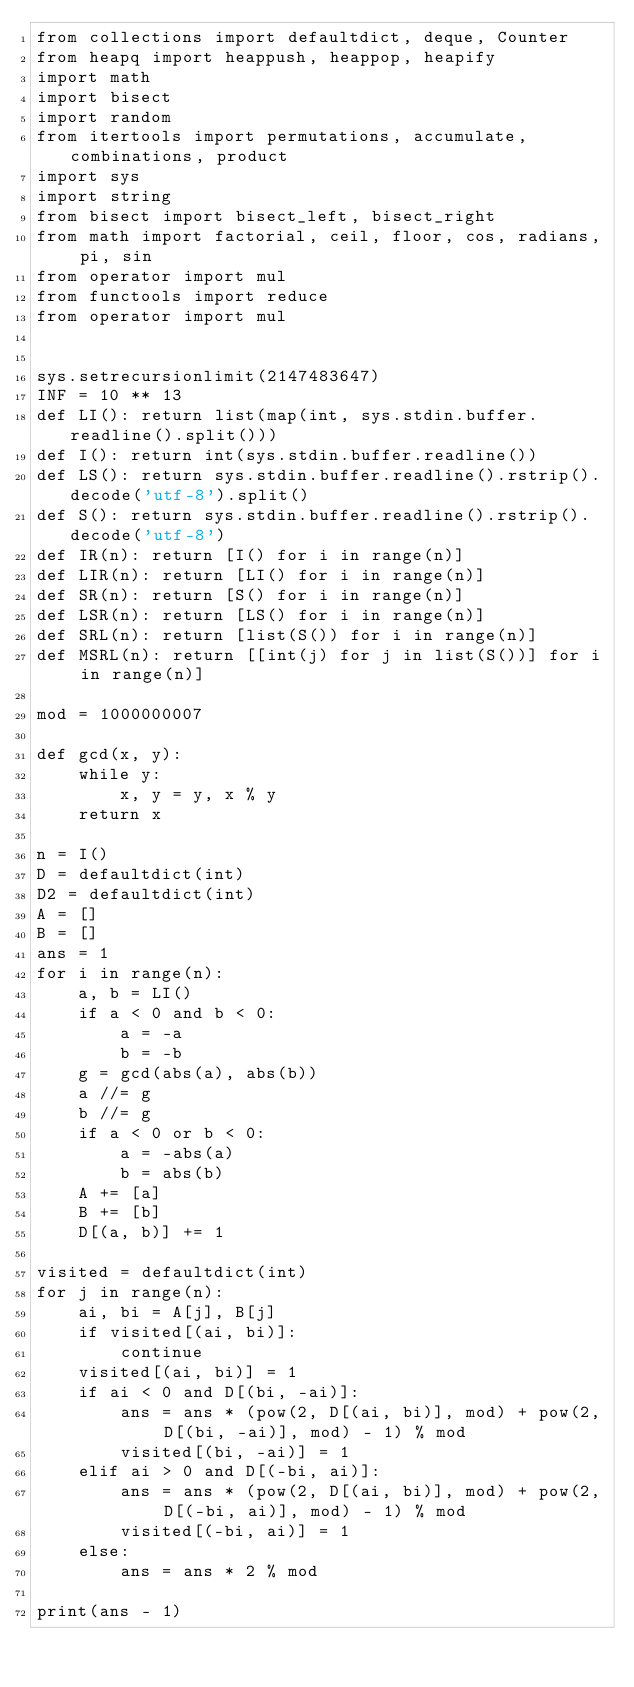<code> <loc_0><loc_0><loc_500><loc_500><_Python_>from collections import defaultdict, deque, Counter
from heapq import heappush, heappop, heapify
import math
import bisect
import random
from itertools import permutations, accumulate, combinations, product
import sys
import string
from bisect import bisect_left, bisect_right
from math import factorial, ceil, floor, cos, radians, pi, sin
from operator import mul
from functools import reduce
from operator import mul


sys.setrecursionlimit(2147483647)
INF = 10 ** 13
def LI(): return list(map(int, sys.stdin.buffer.readline().split()))
def I(): return int(sys.stdin.buffer.readline())
def LS(): return sys.stdin.buffer.readline().rstrip().decode('utf-8').split()
def S(): return sys.stdin.buffer.readline().rstrip().decode('utf-8')
def IR(n): return [I() for i in range(n)]
def LIR(n): return [LI() for i in range(n)]
def SR(n): return [S() for i in range(n)]
def LSR(n): return [LS() for i in range(n)]
def SRL(n): return [list(S()) for i in range(n)]
def MSRL(n): return [[int(j) for j in list(S())] for i in range(n)]

mod = 1000000007

def gcd(x, y):
    while y:
        x, y = y, x % y
    return x

n = I()
D = defaultdict(int)
D2 = defaultdict(int)
A = []
B = []
ans = 1
for i in range(n):
    a, b = LI()
    if a < 0 and b < 0:
        a = -a
        b = -b
    g = gcd(abs(a), abs(b))
    a //= g
    b //= g
    if a < 0 or b < 0:
        a = -abs(a)
        b = abs(b)
    A += [a]
    B += [b]
    D[(a, b)] += 1

visited = defaultdict(int)
for j in range(n):
    ai, bi = A[j], B[j]
    if visited[(ai, bi)]:
        continue
    visited[(ai, bi)] = 1
    if ai < 0 and D[(bi, -ai)]:
        ans = ans * (pow(2, D[(ai, bi)], mod) + pow(2, D[(bi, -ai)], mod) - 1) % mod
        visited[(bi, -ai)] = 1
    elif ai > 0 and D[(-bi, ai)]:
        ans = ans * (pow(2, D[(ai, bi)], mod) + pow(2, D[(-bi, ai)], mod) - 1) % mod
        visited[(-bi, ai)] = 1
    else:
        ans = ans * 2 % mod

print(ans - 1)
</code> 